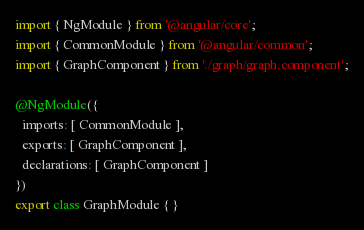Convert code to text. <code><loc_0><loc_0><loc_500><loc_500><_TypeScript_>import { NgModule } from '@angular/core';
import { CommonModule } from '@angular/common';
import { GraphComponent } from './graph/graph.component';

@NgModule({
  imports: [ CommonModule ],
  exports: [ GraphComponent ],
  declarations: [ GraphComponent ]
})
export class GraphModule { }
</code> 